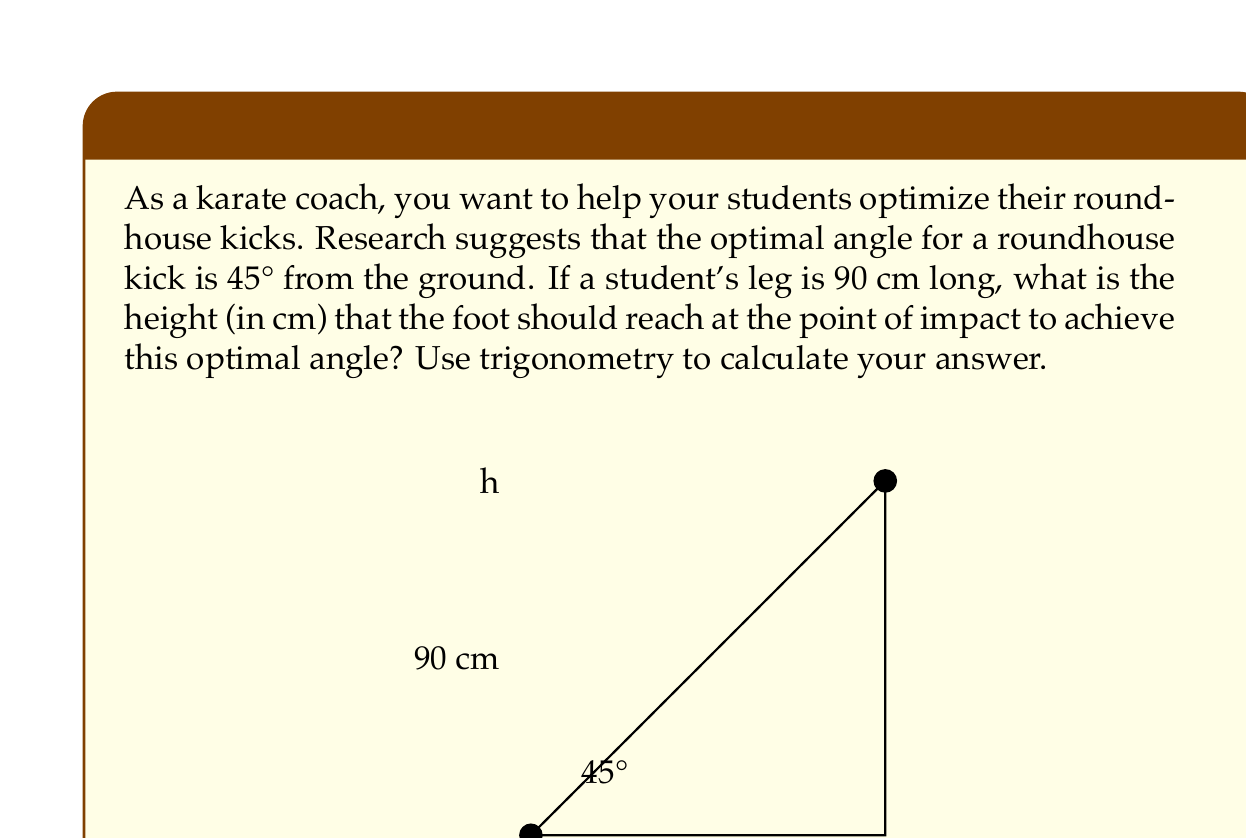Give your solution to this math problem. Let's approach this step-by-step using trigonometry:

1) In a right-angled triangle, we can use the sine function to find the height.

2) The sine of an angle in a right triangle is the ratio of the opposite side to the hypotenuse.

3) In this case:
   - The angle is 45°
   - The hypotenuse is the leg length, 90 cm
   - The opposite side is the height we're looking for, let's call it $h$

4) We can set up the equation:

   $$\sin(45°) = \frac{h}{90}$$

5) To solve for $h$, we multiply both sides by 90:

   $$h = 90 \cdot \sin(45°)$$

6) We know that $\sin(45°) = \frac{\sqrt{2}}{2}$, so:

   $$h = 90 \cdot \frac{\sqrt{2}}{2}$$

7) Simplify:

   $$h = 45\sqrt{2}$$

8) To get a decimal approximation:

   $$h \approx 63.64 \text{ cm}$$

Therefore, the foot should reach a height of approximately 63.64 cm at the point of impact to achieve the optimal 45° angle for a roundhouse kick.
Answer: $h = 45\sqrt{2} \approx 63.64 \text{ cm}$ 